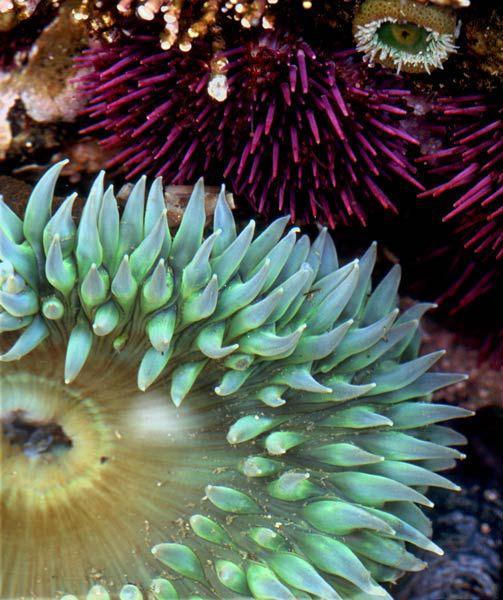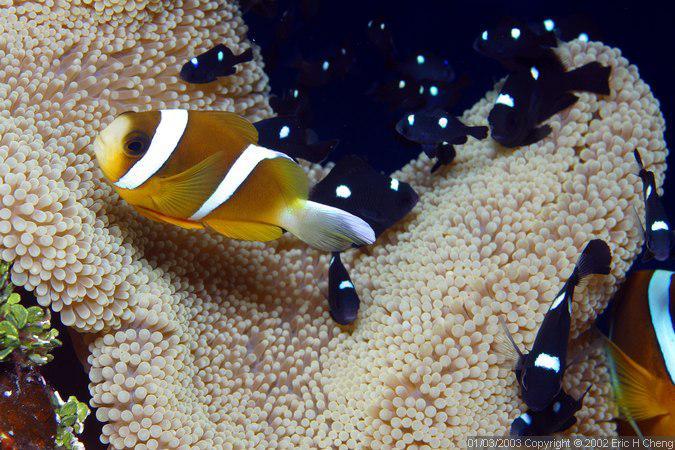The first image is the image on the left, the second image is the image on the right. Examine the images to the left and right. Is the description "There are at least 10 small black and white fish swimming through corral." accurate? Answer yes or no. Yes. The first image is the image on the left, the second image is the image on the right. Assess this claim about the two images: "One image includes at least ten dark fish with white dots swimming above one large, pale, solid-colored anemone.". Correct or not? Answer yes or no. Yes. 